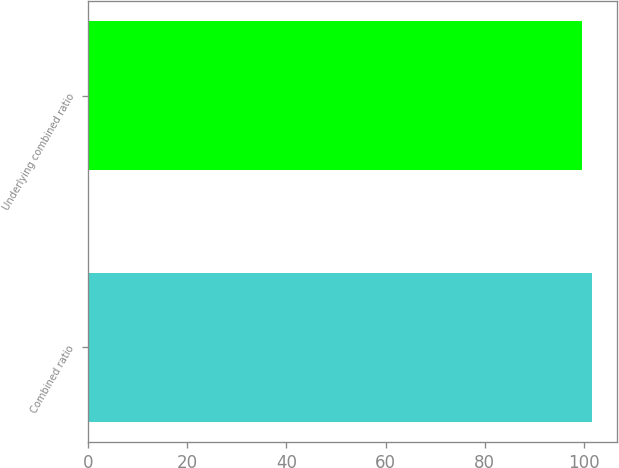Convert chart to OTSL. <chart><loc_0><loc_0><loc_500><loc_500><bar_chart><fcel>Combined ratio<fcel>Underlying combined ratio<nl><fcel>101.6<fcel>99.7<nl></chart> 